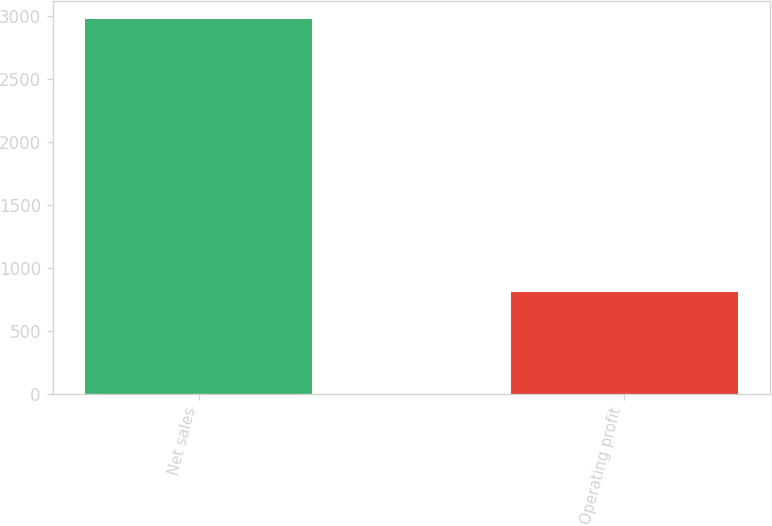<chart> <loc_0><loc_0><loc_500><loc_500><bar_chart><fcel>Net sales<fcel>Operating profit<nl><fcel>2971<fcel>810<nl></chart> 